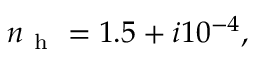Convert formula to latex. <formula><loc_0><loc_0><loc_500><loc_500>n _ { h } = 1 . 5 + i 1 0 ^ { - 4 } ,</formula> 